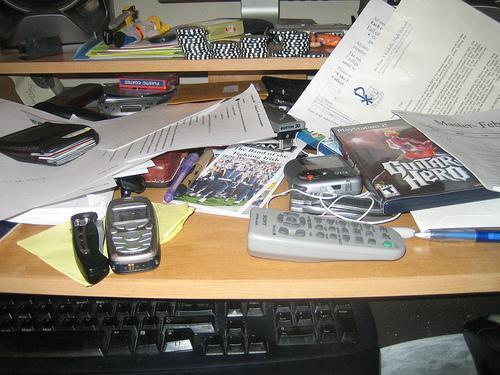How many remotes do you see?
Give a very brief answer. 1. How many books can be seen?
Give a very brief answer. 2. How many people are surf boards are in this picture?
Give a very brief answer. 0. 